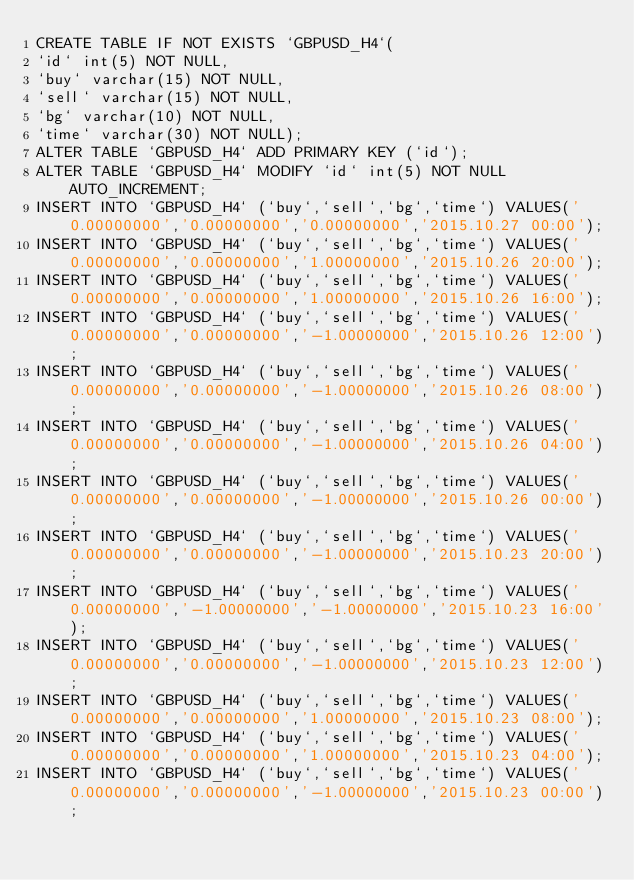<code> <loc_0><loc_0><loc_500><loc_500><_SQL_>CREATE TABLE IF NOT EXISTS `GBPUSD_H4`(
`id` int(5) NOT NULL,
`buy` varchar(15) NOT NULL,
`sell` varchar(15) NOT NULL,
`bg` varchar(10) NOT NULL,
`time` varchar(30) NOT NULL);
ALTER TABLE `GBPUSD_H4` ADD PRIMARY KEY (`id`);
ALTER TABLE `GBPUSD_H4` MODIFY `id` int(5) NOT NULL AUTO_INCREMENT;
INSERT INTO `GBPUSD_H4` (`buy`,`sell`,`bg`,`time`) VALUES('0.00000000','0.00000000','0.00000000','2015.10.27 00:00');
INSERT INTO `GBPUSD_H4` (`buy`,`sell`,`bg`,`time`) VALUES('0.00000000','0.00000000','1.00000000','2015.10.26 20:00');
INSERT INTO `GBPUSD_H4` (`buy`,`sell`,`bg`,`time`) VALUES('0.00000000','0.00000000','1.00000000','2015.10.26 16:00');
INSERT INTO `GBPUSD_H4` (`buy`,`sell`,`bg`,`time`) VALUES('0.00000000','0.00000000','-1.00000000','2015.10.26 12:00');
INSERT INTO `GBPUSD_H4` (`buy`,`sell`,`bg`,`time`) VALUES('0.00000000','0.00000000','-1.00000000','2015.10.26 08:00');
INSERT INTO `GBPUSD_H4` (`buy`,`sell`,`bg`,`time`) VALUES('0.00000000','0.00000000','-1.00000000','2015.10.26 04:00');
INSERT INTO `GBPUSD_H4` (`buy`,`sell`,`bg`,`time`) VALUES('0.00000000','0.00000000','-1.00000000','2015.10.26 00:00');
INSERT INTO `GBPUSD_H4` (`buy`,`sell`,`bg`,`time`) VALUES('0.00000000','0.00000000','-1.00000000','2015.10.23 20:00');
INSERT INTO `GBPUSD_H4` (`buy`,`sell`,`bg`,`time`) VALUES('0.00000000','-1.00000000','-1.00000000','2015.10.23 16:00');
INSERT INTO `GBPUSD_H4` (`buy`,`sell`,`bg`,`time`) VALUES('0.00000000','0.00000000','-1.00000000','2015.10.23 12:00');
INSERT INTO `GBPUSD_H4` (`buy`,`sell`,`bg`,`time`) VALUES('0.00000000','0.00000000','1.00000000','2015.10.23 08:00');
INSERT INTO `GBPUSD_H4` (`buy`,`sell`,`bg`,`time`) VALUES('0.00000000','0.00000000','1.00000000','2015.10.23 04:00');
INSERT INTO `GBPUSD_H4` (`buy`,`sell`,`bg`,`time`) VALUES('0.00000000','0.00000000','-1.00000000','2015.10.23 00:00');</code> 